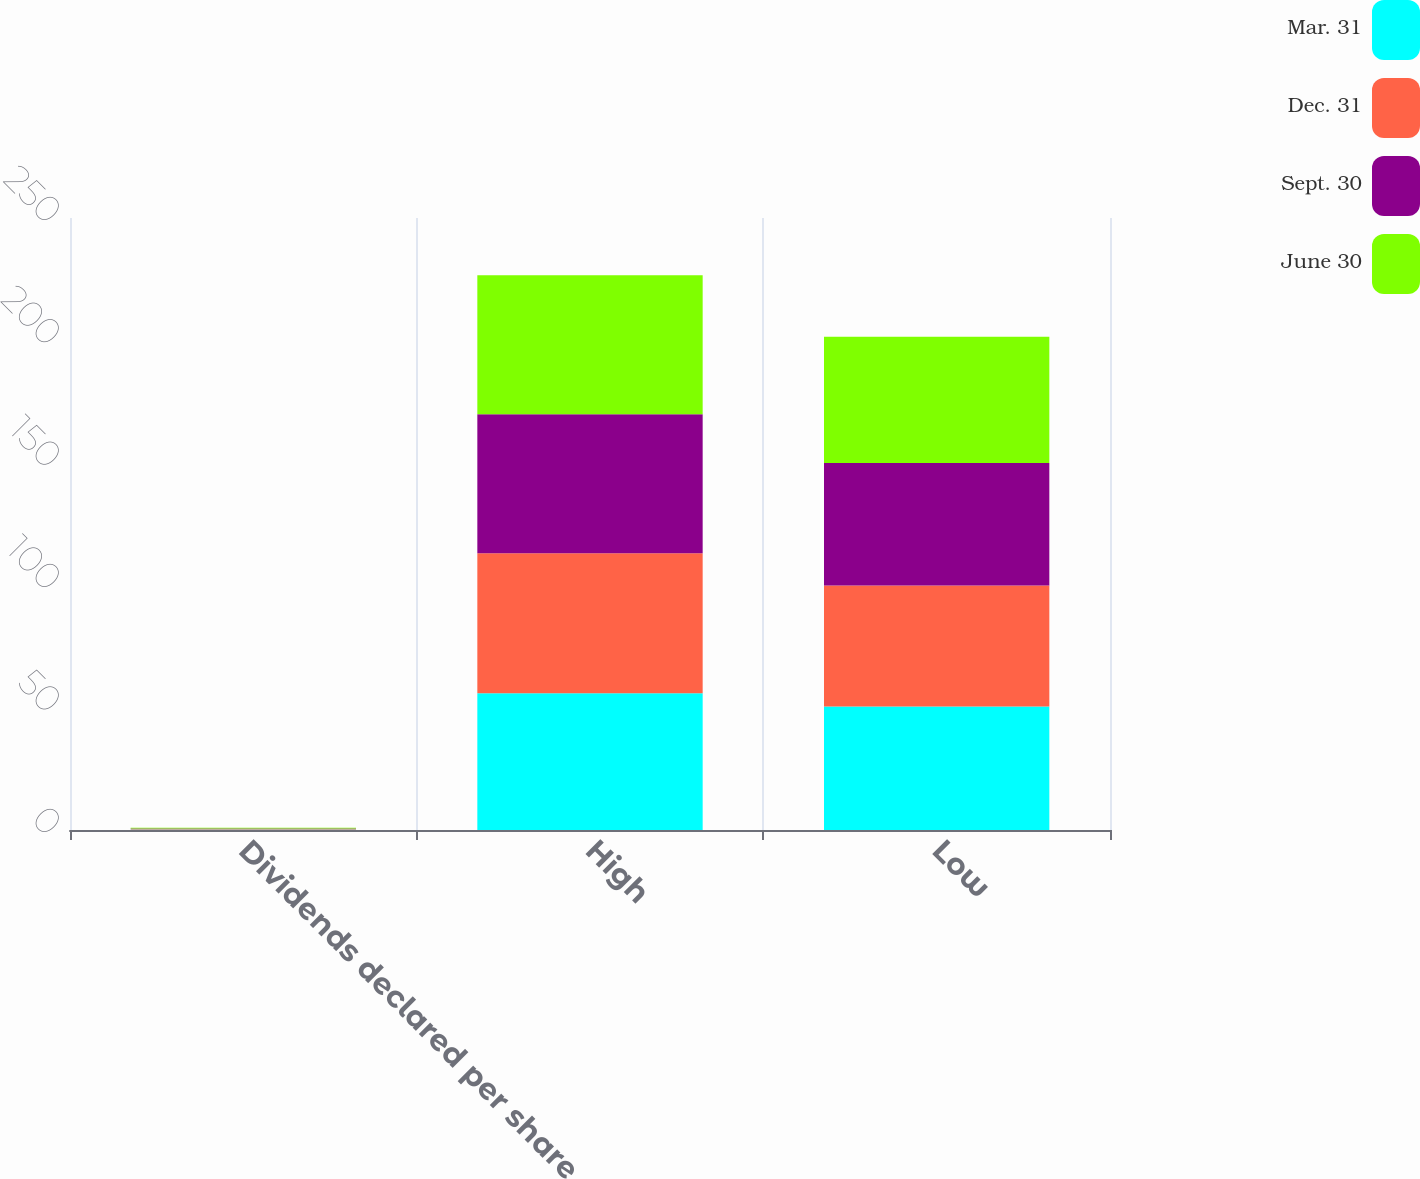Convert chart. <chart><loc_0><loc_0><loc_500><loc_500><stacked_bar_chart><ecel><fcel>Dividends declared per share<fcel>High<fcel>Low<nl><fcel>Mar. 31<fcel>0.21<fcel>55.9<fcel>50.41<nl><fcel>Dec. 31<fcel>0.21<fcel>57.14<fcel>49.43<nl><fcel>Sept. 30<fcel>0.21<fcel>56.79<fcel>50.05<nl><fcel>June 30<fcel>0.27<fcel>56.75<fcel>51.6<nl></chart> 